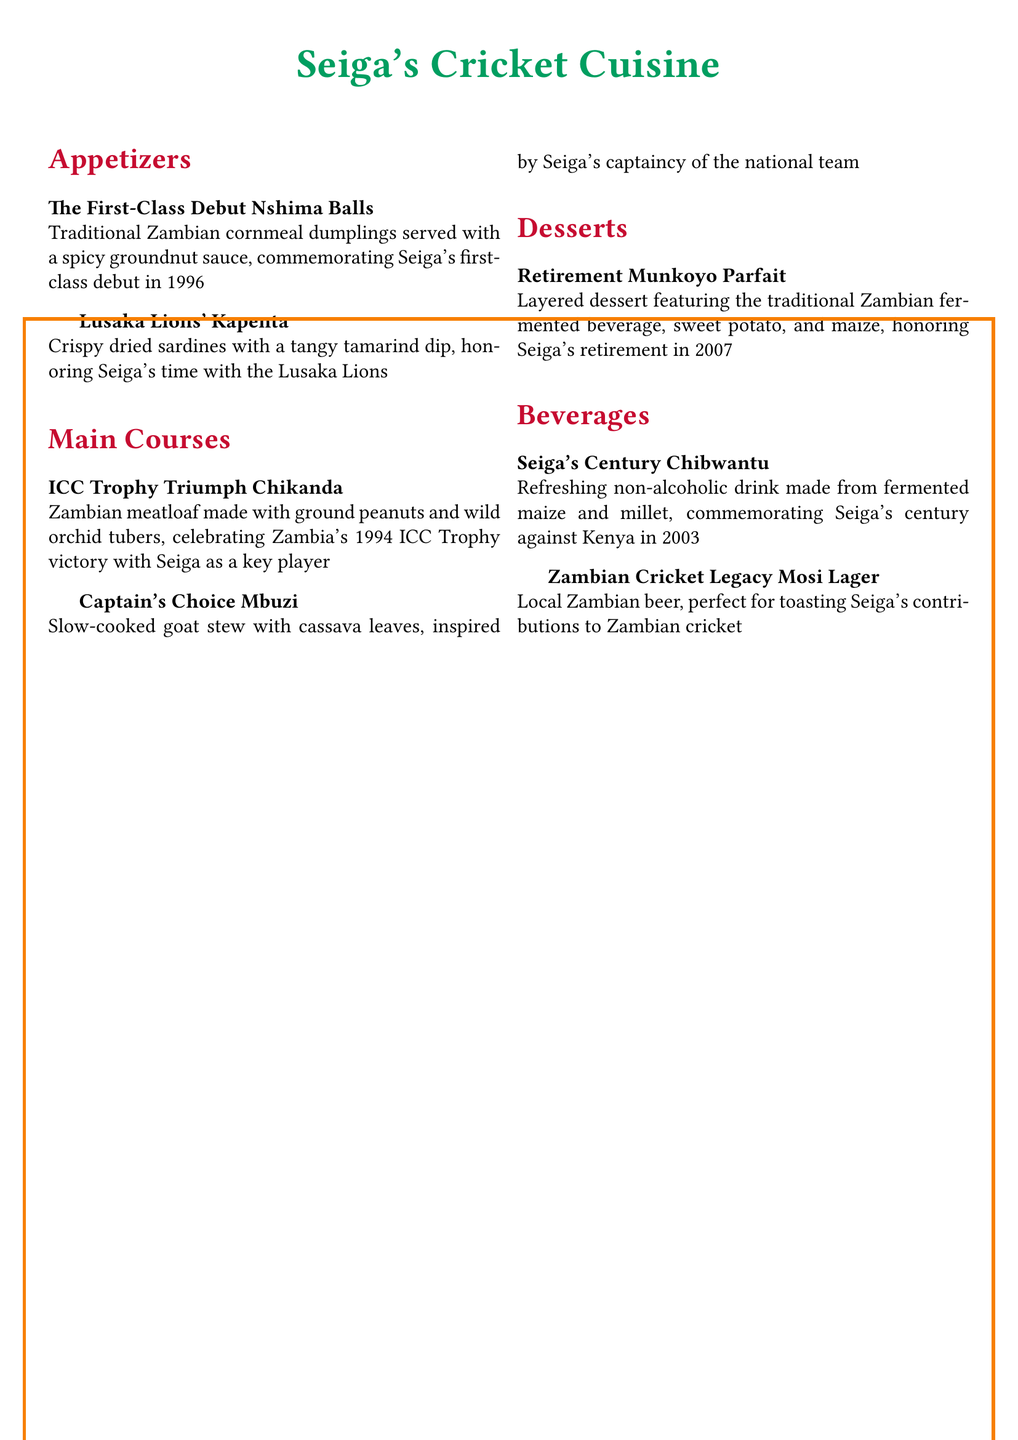What is the name of the first appetizer? The first appetizer listed is "The First-Class Debut Nshima Balls" in the document.
Answer: The First-Class Debut Nshima Balls What year did Asadu Seiga make his first-class debut? The document states that Seiga's first-class debut was in 1996.
Answer: 1996 What does the mains course "Captain's Choice Mbuzi" consist of? The main course "Captain's Choice Mbuzi" is described as a slow-cooked goat stew with cassava leaves.
Answer: Goat stew with cassava leaves What beverage commemorates Seiga's century against Kenya? The beverage named after Seiga's century against Kenya is "Seiga's Century Chibwantu."
Answer: Seiga's Century Chibwantu How many appetizers are listed on the menu? The menu features two appetizers: "The First-Class Debut Nshima Balls" and "Lusaka Lions' Kapenta."
Answer: Two What is the significance of the dessert "Retirement Munkoyo Parfait"? This dessert honors Seiga's retirement in 2007.
Answer: Seiga's retirement in 2007 Which main course celebrates Zambia's 1994 ICC Trophy victory? The main course celebrating the 1994 ICC Trophy victory is "ICC Trophy Triumph Chikanda."
Answer: ICC Trophy Triumph Chikanda What type of beverage is "Zambian Cricket Legacy Mosi Lager"? The beverage is a local Zambian beer.
Answer: Local Zambian beer What is the primary ingredient in "ICC Trophy Triumph Chikanda"? The primary ingredient in "ICC Trophy Triumph Chikanda" is ground peanuts.
Answer: Ground peanuts 